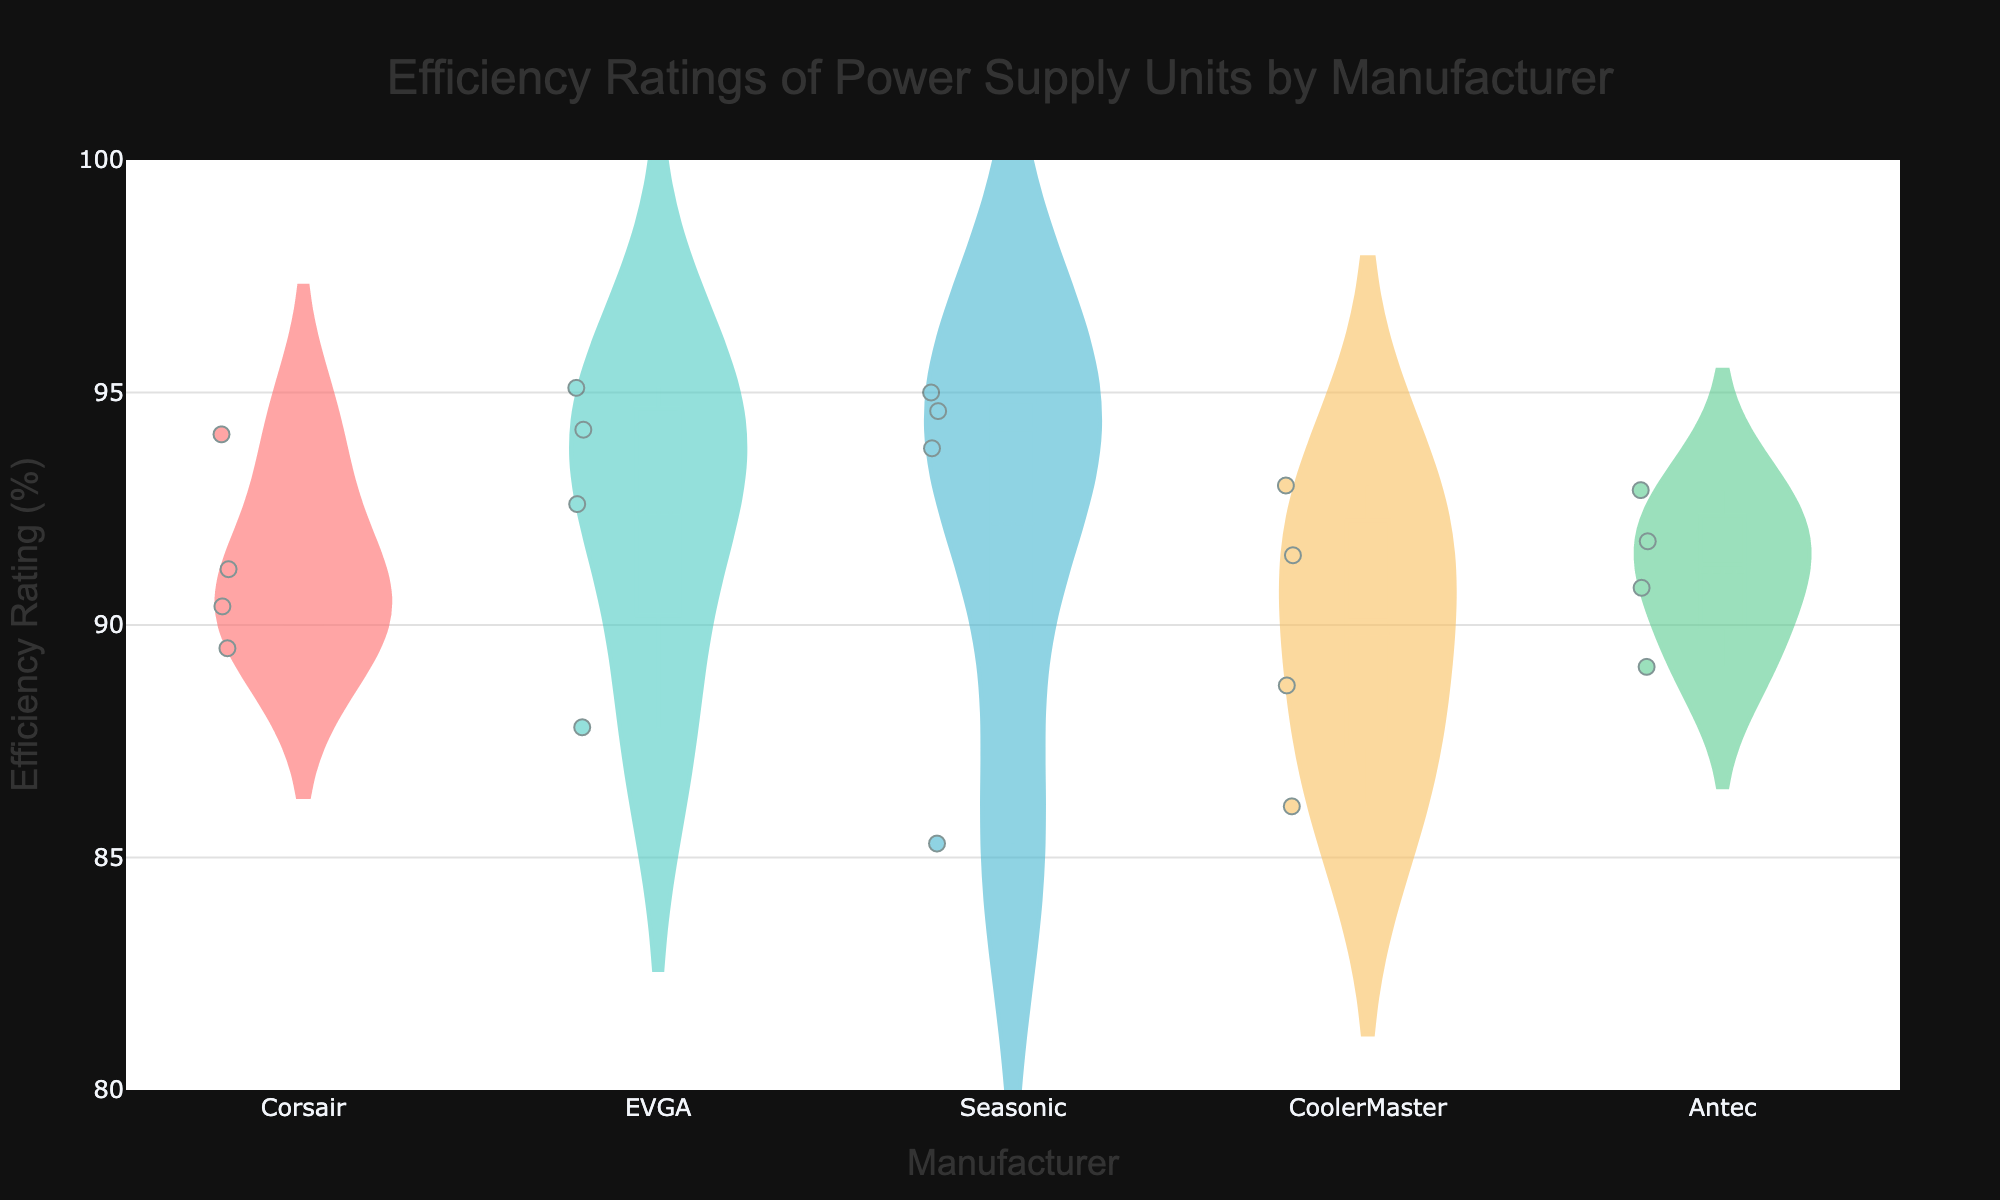What is the median efficiency rating for Corsair? To find the median efficiency rating of Corsair, locate the box plot within the violin that represents Corsair and look for the middle line within the box. This line represents the median value.
Answer: 90.8% Which manufacturer has the highest maximum efficiency rating? Look at the topmost points of the violins for each manufacturer to determine the highest efficiency rating among all manufacturers. The manufacturer whose violin has the highest top point in this graph has the highest maximum efficiency rating.
Answer: EVGA How does the mean efficiency rating of all Antec models compare to that of CoolerMaster models? Look for the mean line in the box plot inside the violin for both Antec and CoolerMaster. Compare their positions. Calculate or visually estimate the mean efficiency rating for both, then compare them.
Answer: Antec has a slightly higher mean efficiency than CoolerMaster Which manufacturer's models show the greatest variability in efficiency rating? To determine variability, compare the lengths of the violins for each manufacturer. The manufacturer with the widest spread from top to bottom has the greatest variability.
Answer: Seasonic What is the range of efficiency ratings for Seasonic's models? The range is found by subtracting the minimum data point in Seasonic's violin from the maximum data point in the same violin. Identify the lowest and highest points of Seasonic's violin to compute the range.
Answer: 95.0 - 85.3 = 9.7 Are there any outliers in CoolerMaster's efficiency ratings? To identify outliers, look at the points that fall outside of the box plot whiskers in the violin for CoolerMaster. Points that are isolated and distant from the main body represent outliers.
Answer: Yes, there are a few outliers Which manufacturer has the smallest interquartile range (IQR) for efficiency ratings? The IQR can be observed within the box plot as the length of the box for each manufacturer. The manufacturer with the smallest box has the smallest IQR.
Answer: Antec How many manufacturers have a mean efficiency rating above 92%? Identify the mean lines inside the box plots within the violins for each manufacturer and count how many of these lines are above the 92% mark.
Answer: 3 Which model has the lowest efficiency rating, and what is its value? Locate the lowest point in all violins and identify the model corresponding to that point.
Answer: Seasonic S12III 500W with 85.3% What is the median efficiency rating for all manufacturers combined? To determine the overall median, you must combine all data points from all manufacturers and then find the middle value. This may not be directly visible from the graph and might need external calculation or estimation.
Answer: Approximately 91% 